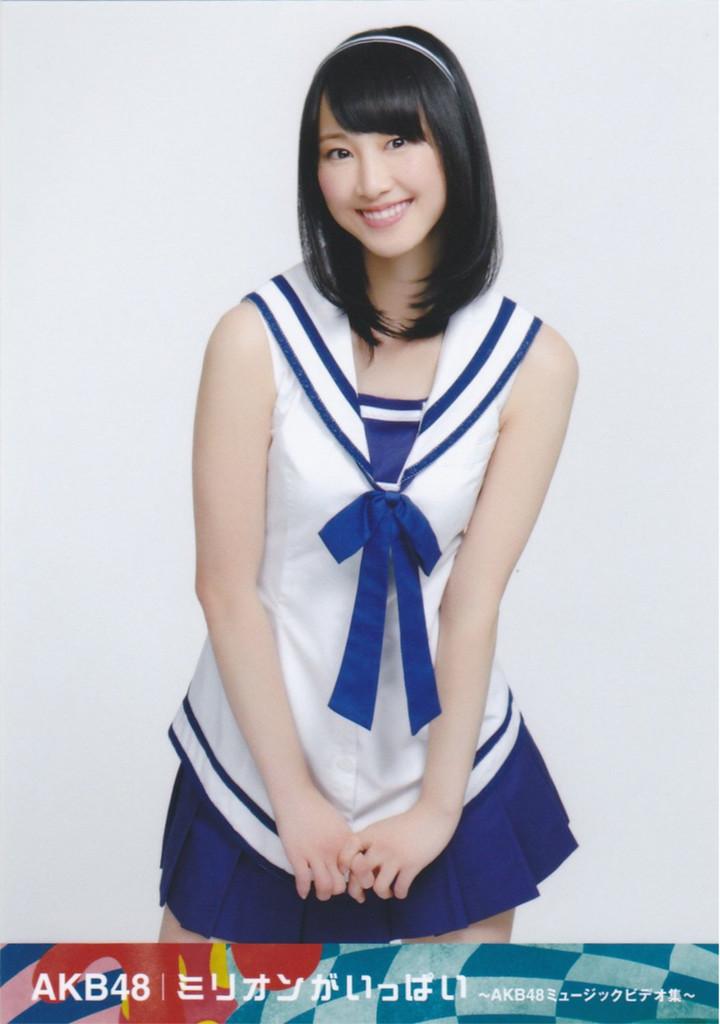What is written at the bottom?
Your answer should be very brief. Akb48. Is the language of the text korean?
Provide a short and direct response. Unanswerable. 